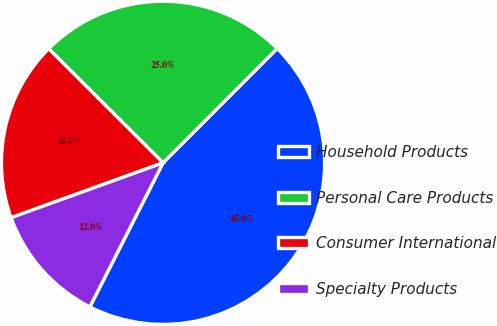Convert chart to OTSL. <chart><loc_0><loc_0><loc_500><loc_500><pie_chart><fcel>Household Products<fcel>Personal Care Products<fcel>Consumer International<fcel>Specialty Products<nl><fcel>45.0%<fcel>25.0%<fcel>18.0%<fcel>12.0%<nl></chart> 